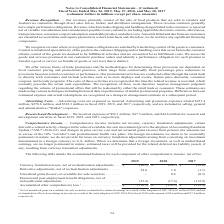According to Conagra Brands's financial document, What does comprehensive income comprise of? net income, currency translation adjustments, certain derivative-related activity, changes in the value of available-for-sale investments (prior to the adoption of Accounting Standards Update ("ASU") 2016-01), and changes in prior service cost and net actuarial gains (losses) from pension (for amounts not in excess of the 10% "corridor") and postretirement health care plans. The document states: "prehensive Income — Comprehensive income includes net income, currency translation adjustments, certain derivative-related activity, changes in the va..." Also, What does the table show us? the accumulated balances for each component of other comprehensive income, net of tax. The document states: "The following table details the accumulated balances for each component of other comprehensive income, net of tax:..." Also, What are the balances for derivative adjustments (net of reclassification adjustments, in millions) for 2017, 2018 and 2019, respectively? The document contains multiple relevant values: (1.1), 1.0, 34.0. From the document: "ents, net of reclassification adjustments. . 34.0 1.0 (1.1) justments, net of reclassification adjustments. . 34.0 1.0 (1.1) s, net of reclassificatio..." Also, can you calculate: What is the percentage change of accumulated other comprehensive loss in 2018 compared to 2017? To answer this question, I need to perform calculations using the financial data. The calculation is: (-110.5-(-212.9))/(-212.9) , which equals -48.1 (percentage). This is based on the information: "her comprehensive loss 1 . $ (110.3) $ (110.5) $ (212.9) mulated other comprehensive loss 1 . $ (110.3) $ (110.5) $ (212.9)..." The key data points involved are: 110.5, 212.9. Also, can you calculate: What are the proportion of currency translation losses and derivative adjustments over accumulated other comprehensive loss in 2017? To answer this question, I need to perform calculations using the financial data. The calculation is: (-98.6+(-1.1))/(-212.9) , which equals 0.47. This is based on the information: "net of reclassification adjustments. . 34.0 1.0 (1.1) her comprehensive loss 1 . $ (110.3) $ (110.5) $ (212.9) classification adjustments . $ (90.9) $ (94.7) $ (98.6)..." The key data points involved are: 1.1, 212.9, 98.6. Also, can you calculate: What is the total balance of pension and post-employment benefit obligations from 2017 to 2019? Based on the calculation: -112.9+(-17.4)+(-53.4) , the result is -183.7 (in millions). This is based on the information: "of reclassification adjustments . (53.4) (17.4) (112.9) ns, net of reclassification adjustments . (53.4) (17.4) (112.9) ligations, net of reclassification adjustments . (53.4) (17.4) (112.9)..." The key data points involved are: 112.9, 17.4, 53.4. 